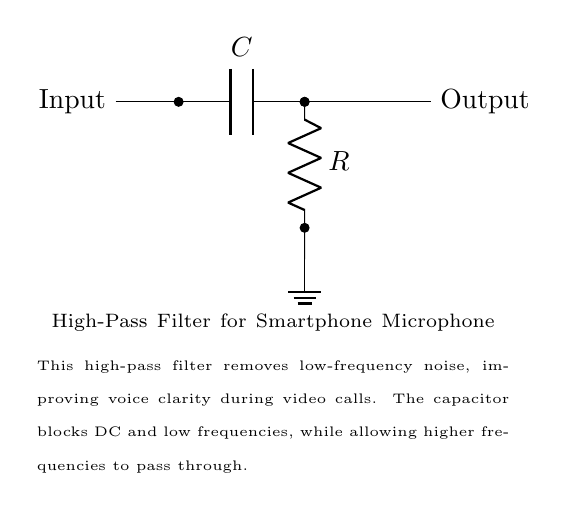What component is used to block low frequencies? The capacitor is included in the circuit to block low-frequency signals while allowing higher frequencies to pass. It is positioned between the input and the output.
Answer: Capacitor What is the function of the resistor in this circuit? The resistor typically works in conjunction with the capacitor to define the cutoff frequency of the high-pass filter. It allows the circuit to control the rate at which signals are passed through based on their frequency.
Answer: To set cutoff frequency What is the output of this circuit? The output is the processed audio signal that has had low-frequency noise filtered out, resulting in improved voice clarity for video calls.
Answer: Filtered audio signal What type of filter is represented in this circuit? The circuit represents a high-pass filter, as it is designed to allow signals above a certain frequency to pass while blocking signals below that frequency.
Answer: High-pass filter What would happen if the capacitor value is increased? Increasing the capacitor value would lower the cutoff frequency, allowing more low-frequency signals to pass through instead of blocking them, potentially reducing clarity in voice calls.
Answer: Lower cutoff frequency What does the ground symbol indicate in this circuit? The ground symbol serves as a common reference point for voltage levels in the circuit and provides a return path for current, ensuring stable operation.
Answer: Common reference point What happens to signals below the cutoff frequency? Signals below the cutoff frequency are blocked by the capacitor, which prevents them from reaching the output, thereby improving the quality of the transmitted audio.
Answer: Blocked 